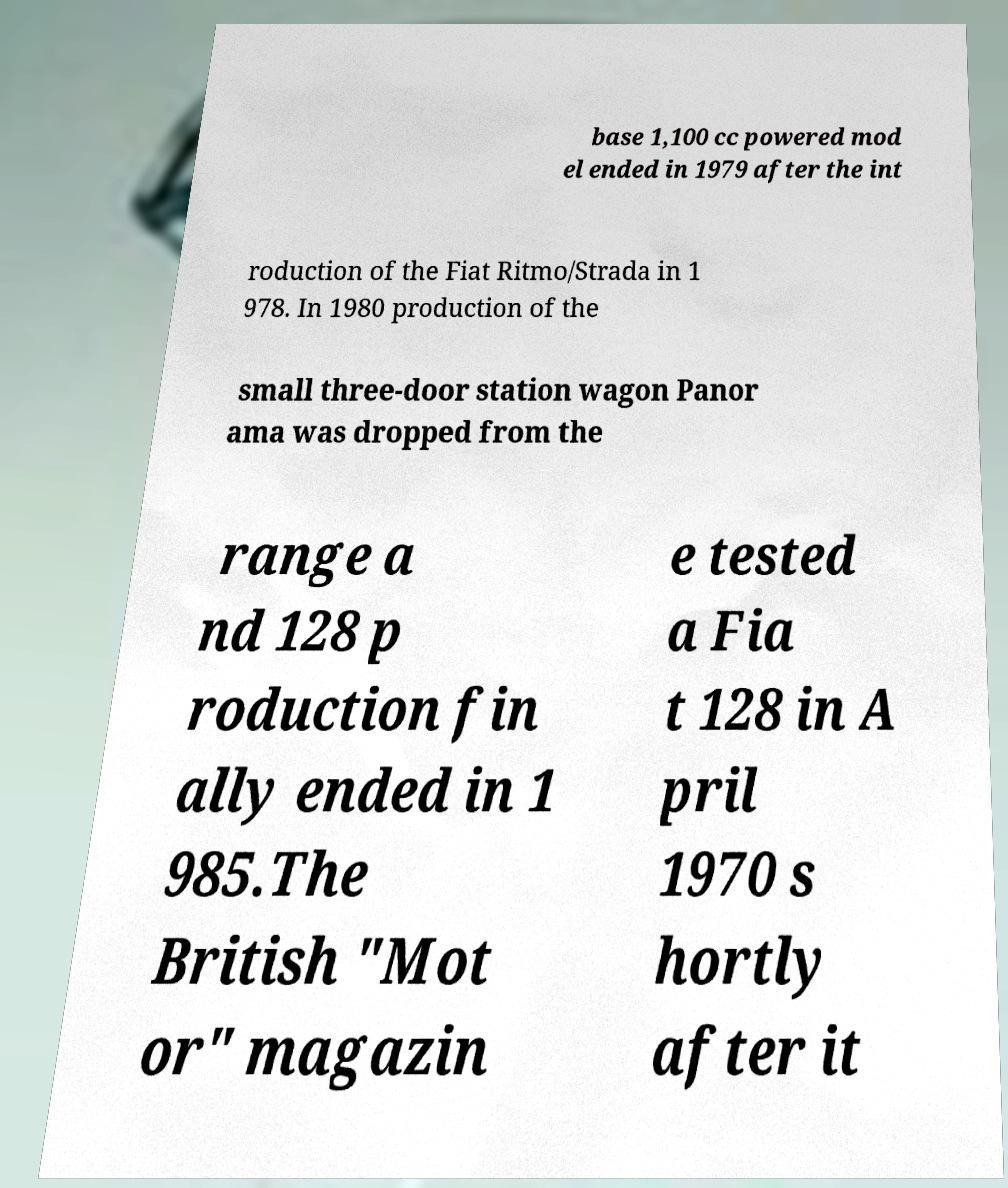Could you extract and type out the text from this image? base 1,100 cc powered mod el ended in 1979 after the int roduction of the Fiat Ritmo/Strada in 1 978. In 1980 production of the small three-door station wagon Panor ama was dropped from the range a nd 128 p roduction fin ally ended in 1 985.The British "Mot or" magazin e tested a Fia t 128 in A pril 1970 s hortly after it 